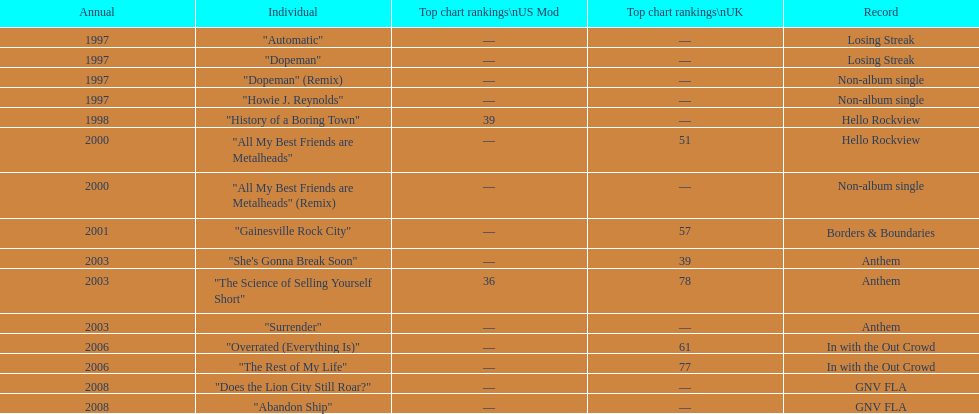How long was it between losing streak almbum and gnv fla in years. 11. 